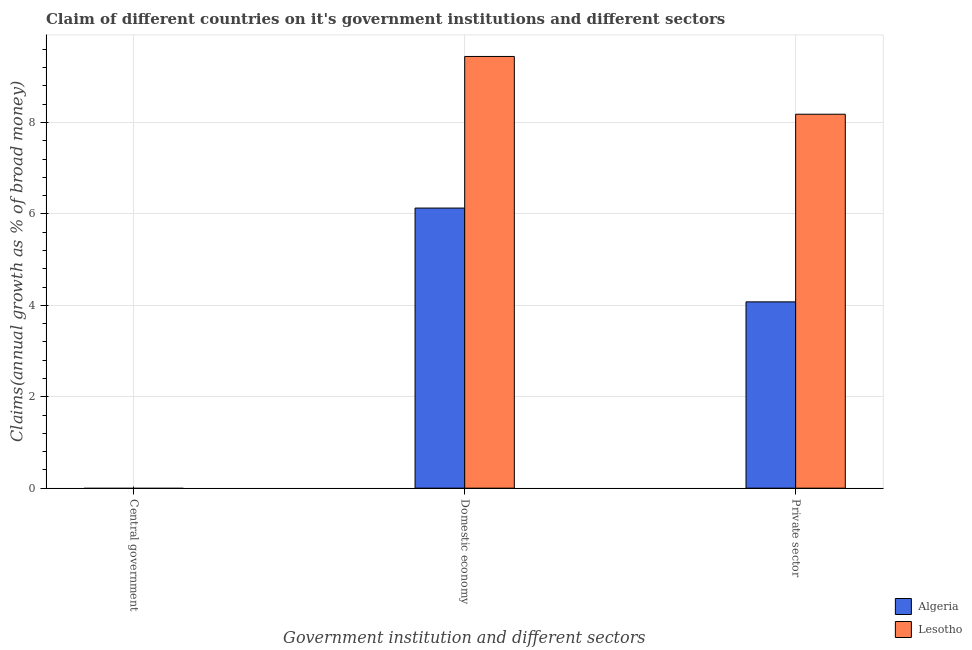Are the number of bars on each tick of the X-axis equal?
Keep it short and to the point. No. How many bars are there on the 3rd tick from the left?
Make the answer very short. 2. How many bars are there on the 3rd tick from the right?
Provide a short and direct response. 0. What is the label of the 2nd group of bars from the left?
Give a very brief answer. Domestic economy. What is the percentage of claim on the central government in Lesotho?
Keep it short and to the point. 0. Across all countries, what is the maximum percentage of claim on the private sector?
Provide a short and direct response. 8.18. Across all countries, what is the minimum percentage of claim on the private sector?
Provide a short and direct response. 4.08. In which country was the percentage of claim on the private sector maximum?
Your response must be concise. Lesotho. What is the total percentage of claim on the private sector in the graph?
Your answer should be compact. 12.26. What is the difference between the percentage of claim on the private sector in Lesotho and that in Algeria?
Make the answer very short. 4.11. What is the difference between the percentage of claim on the domestic economy in Lesotho and the percentage of claim on the private sector in Algeria?
Make the answer very short. 5.37. What is the average percentage of claim on the private sector per country?
Your answer should be very brief. 6.13. What is the difference between the percentage of claim on the private sector and percentage of claim on the domestic economy in Algeria?
Offer a terse response. -2.05. In how many countries, is the percentage of claim on the private sector greater than 3.6 %?
Your answer should be compact. 2. What is the ratio of the percentage of claim on the domestic economy in Lesotho to that in Algeria?
Keep it short and to the point. 1.54. What is the difference between the highest and the second highest percentage of claim on the domestic economy?
Give a very brief answer. 3.32. What is the difference between the highest and the lowest percentage of claim on the domestic economy?
Your response must be concise. 3.32. In how many countries, is the percentage of claim on the domestic economy greater than the average percentage of claim on the domestic economy taken over all countries?
Your answer should be very brief. 1. Is the sum of the percentage of claim on the domestic economy in Lesotho and Algeria greater than the maximum percentage of claim on the central government across all countries?
Your answer should be compact. Yes. Is it the case that in every country, the sum of the percentage of claim on the central government and percentage of claim on the domestic economy is greater than the percentage of claim on the private sector?
Offer a very short reply. Yes. How many countries are there in the graph?
Offer a very short reply. 2. What is the difference between two consecutive major ticks on the Y-axis?
Your answer should be compact. 2. Does the graph contain any zero values?
Provide a short and direct response. Yes. Does the graph contain grids?
Offer a very short reply. Yes. Where does the legend appear in the graph?
Your answer should be compact. Bottom right. How many legend labels are there?
Offer a terse response. 2. How are the legend labels stacked?
Make the answer very short. Vertical. What is the title of the graph?
Your response must be concise. Claim of different countries on it's government institutions and different sectors. What is the label or title of the X-axis?
Keep it short and to the point. Government institution and different sectors. What is the label or title of the Y-axis?
Offer a terse response. Claims(annual growth as % of broad money). What is the Claims(annual growth as % of broad money) of Algeria in Central government?
Offer a terse response. 0. What is the Claims(annual growth as % of broad money) in Algeria in Domestic economy?
Ensure brevity in your answer.  6.13. What is the Claims(annual growth as % of broad money) in Lesotho in Domestic economy?
Ensure brevity in your answer.  9.44. What is the Claims(annual growth as % of broad money) in Algeria in Private sector?
Your answer should be very brief. 4.08. What is the Claims(annual growth as % of broad money) in Lesotho in Private sector?
Your answer should be very brief. 8.18. Across all Government institution and different sectors, what is the maximum Claims(annual growth as % of broad money) of Algeria?
Your response must be concise. 6.13. Across all Government institution and different sectors, what is the maximum Claims(annual growth as % of broad money) of Lesotho?
Offer a very short reply. 9.44. Across all Government institution and different sectors, what is the minimum Claims(annual growth as % of broad money) of Lesotho?
Provide a succinct answer. 0. What is the total Claims(annual growth as % of broad money) in Algeria in the graph?
Keep it short and to the point. 10.2. What is the total Claims(annual growth as % of broad money) in Lesotho in the graph?
Make the answer very short. 17.63. What is the difference between the Claims(annual growth as % of broad money) of Algeria in Domestic economy and that in Private sector?
Ensure brevity in your answer.  2.05. What is the difference between the Claims(annual growth as % of broad money) in Lesotho in Domestic economy and that in Private sector?
Provide a succinct answer. 1.26. What is the difference between the Claims(annual growth as % of broad money) of Algeria in Domestic economy and the Claims(annual growth as % of broad money) of Lesotho in Private sector?
Your answer should be compact. -2.05. What is the average Claims(annual growth as % of broad money) in Algeria per Government institution and different sectors?
Your answer should be very brief. 3.4. What is the average Claims(annual growth as % of broad money) of Lesotho per Government institution and different sectors?
Offer a very short reply. 5.88. What is the difference between the Claims(annual growth as % of broad money) of Algeria and Claims(annual growth as % of broad money) of Lesotho in Domestic economy?
Provide a succinct answer. -3.32. What is the difference between the Claims(annual growth as % of broad money) of Algeria and Claims(annual growth as % of broad money) of Lesotho in Private sector?
Your answer should be very brief. -4.11. What is the ratio of the Claims(annual growth as % of broad money) in Algeria in Domestic economy to that in Private sector?
Provide a succinct answer. 1.5. What is the ratio of the Claims(annual growth as % of broad money) of Lesotho in Domestic economy to that in Private sector?
Keep it short and to the point. 1.15. What is the difference between the highest and the lowest Claims(annual growth as % of broad money) in Algeria?
Offer a terse response. 6.13. What is the difference between the highest and the lowest Claims(annual growth as % of broad money) of Lesotho?
Offer a terse response. 9.44. 